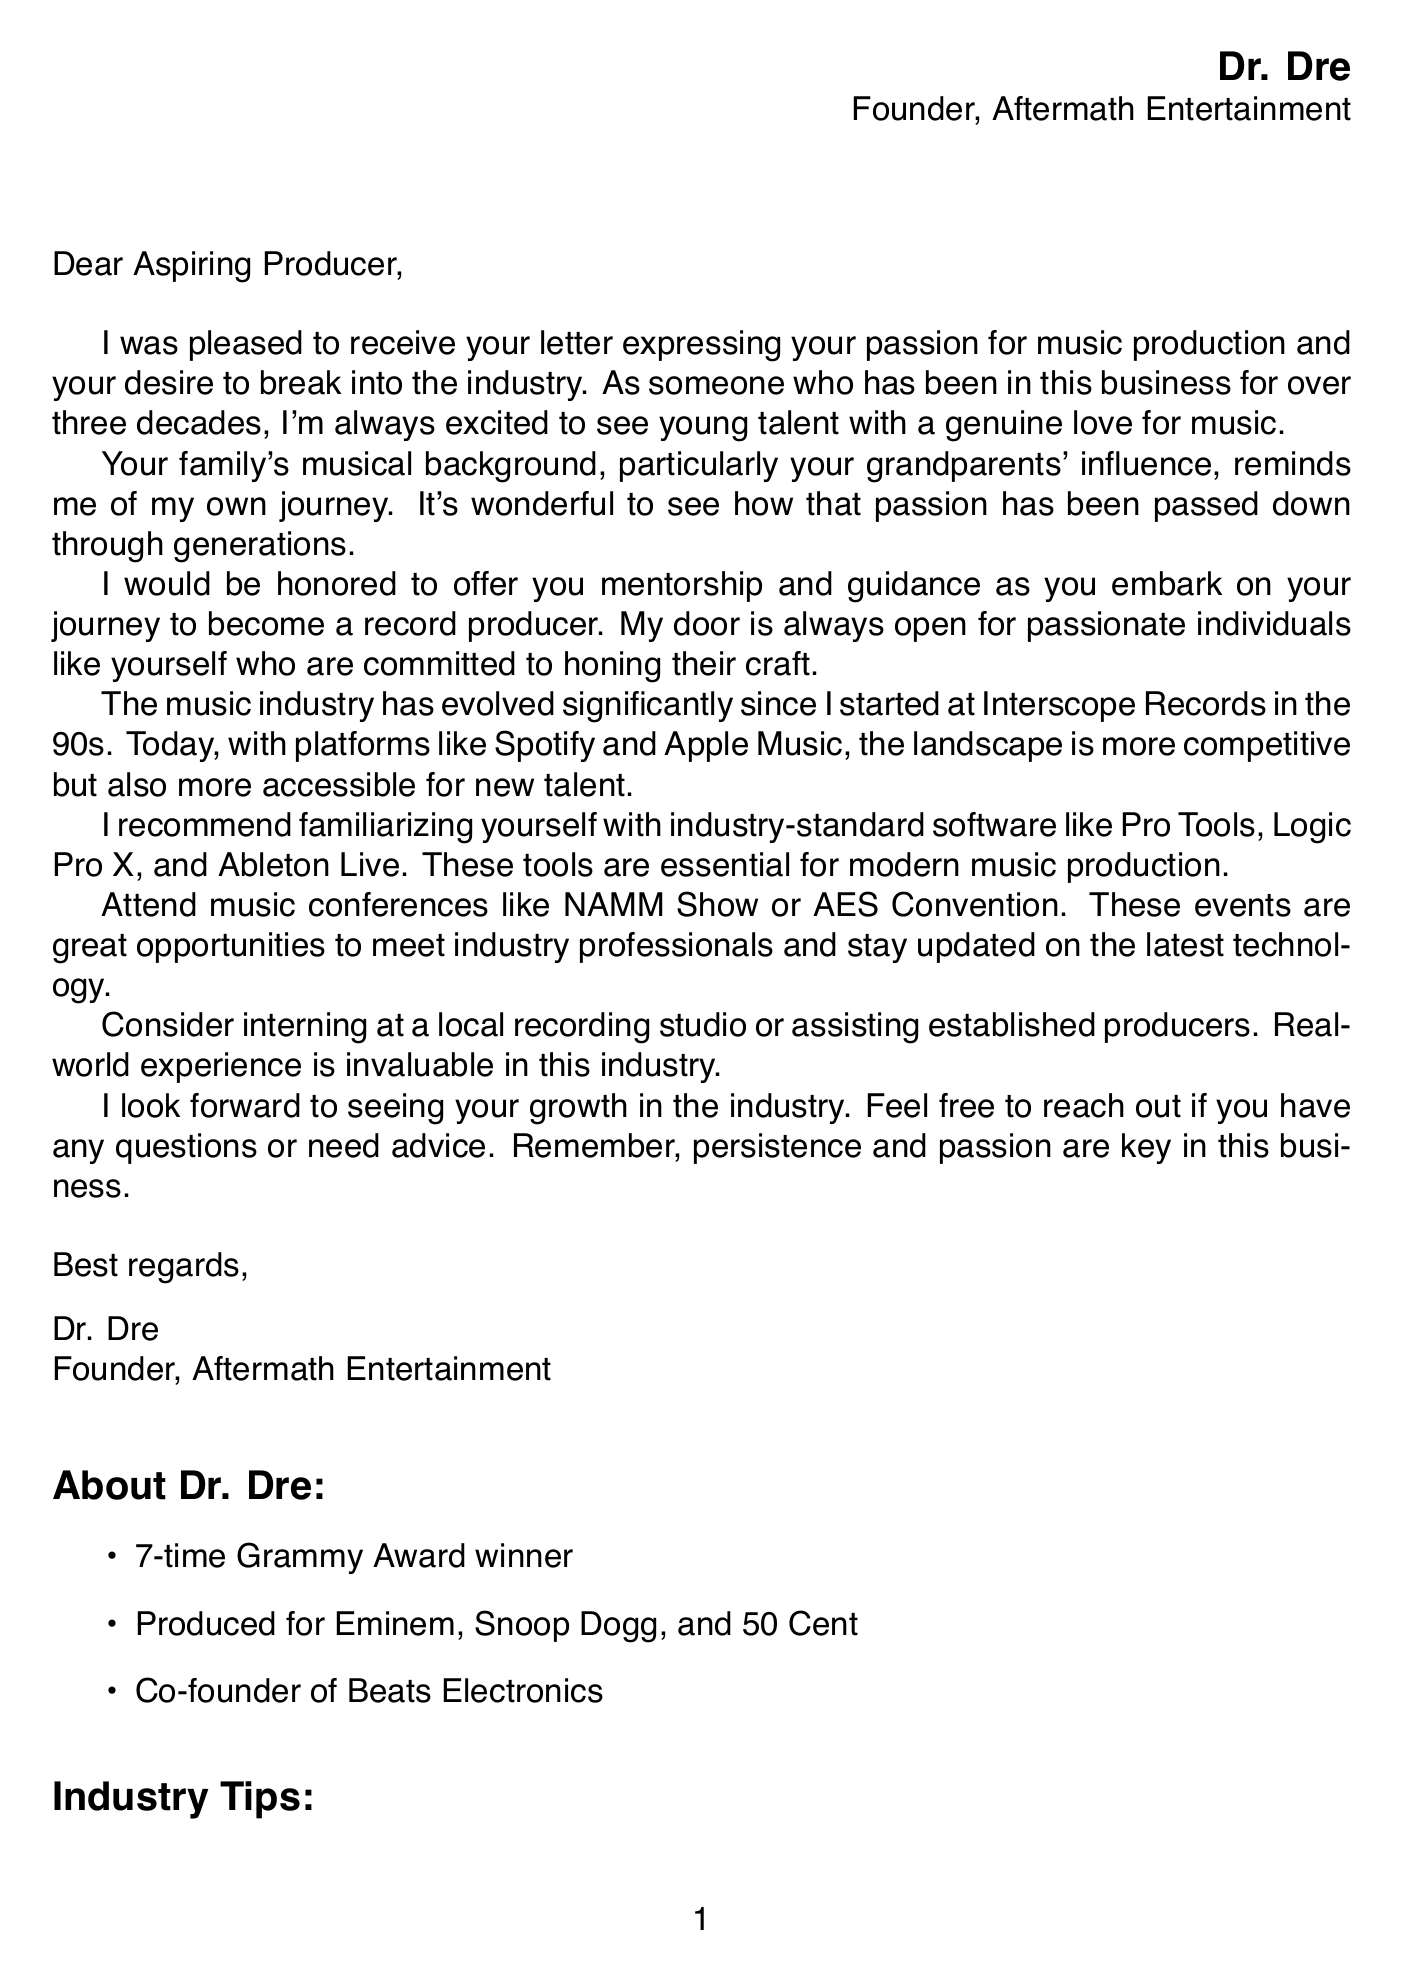What is the name of the renowned record producer? The letter is signed by Dr. Dre, a prominent figure in the music industry.
Answer: Dr. Dre What is the name of Dr. Dre's company? The document states that Dr. Dre is the founder of Aftermath Entertainment.
Answer: Aftermath Entertainment How many Grammy Awards has Dr. Dre won? The document mentions that Dr. Dre is a 7-time Grammy Award winner.
Answer: 7-time What software does Dr. Dre recommend learning? The body paragraph suggests familiarizing with Pro Tools, Logic Pro X, and Ableton Live.
Answer: Pro Tools, Logic Pro X, and Ableton Live What type of events does Dr. Dre recommend attending for networking? The letter advises attending the NAMM Show or AES Convention for meeting industry professionals.
Answer: NAMM Show or AES Convention What personal connection does Dr. Dre mention regarding the aspiring producer's background? He refers to the influence of the aspiring producer's grandparents in their musical background.
Answer: Grandparents' influence What does Dr. Dre emphasize as key qualities for success in the industry? He highlights that persistence and passion are crucial in the music business.
Answer: Persistence and passion What type of organization is The Recording Academy Producers & Engineers Wing? It is noted as a professional organization that offers networking and educational opportunities.
Answer: Professional organization 